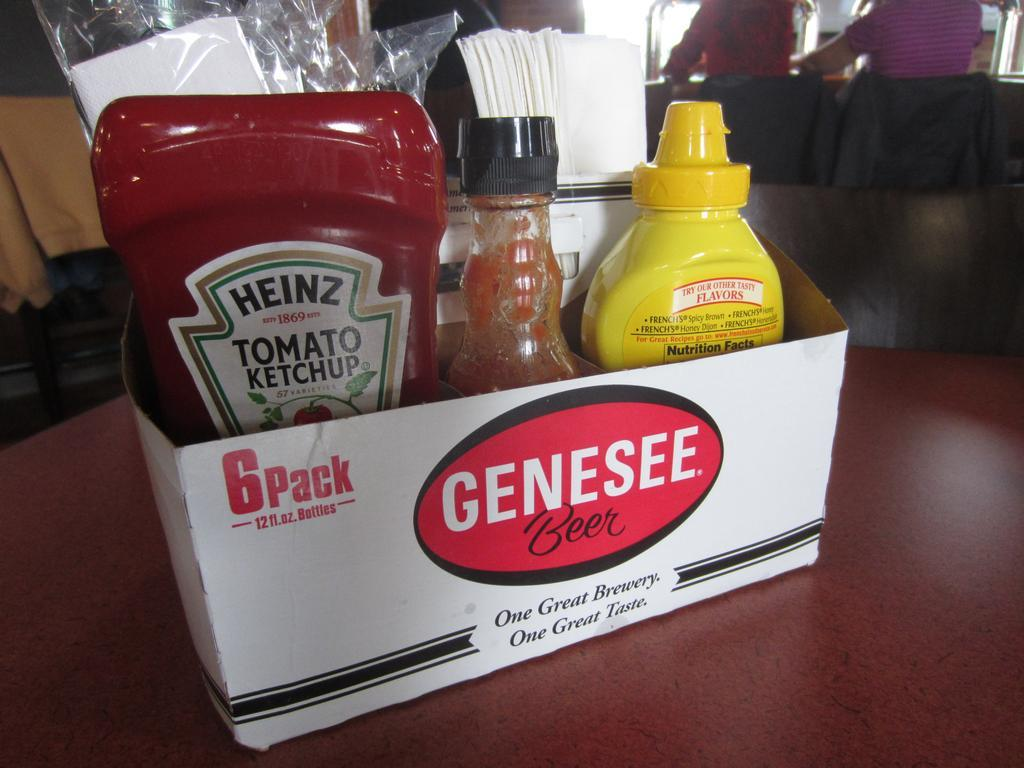How can the choice of these three specific condiments refine our guess about the type of food served? The presence of Heinz Tomato Ketchup, Frank's RedHot Original Cayenne Pepper Sauce, and French's Classic Yellow Mustard suggests that the restaurant serves classic American cuisine. These condiments are commonly associated with foods like burgers, hot dogs, fries, and sandwiches. This selection supports the idea that the menu might include comfort food favorites that are popular in many American diners, inviting a broad range of customers with familiar and beloved flavors. 